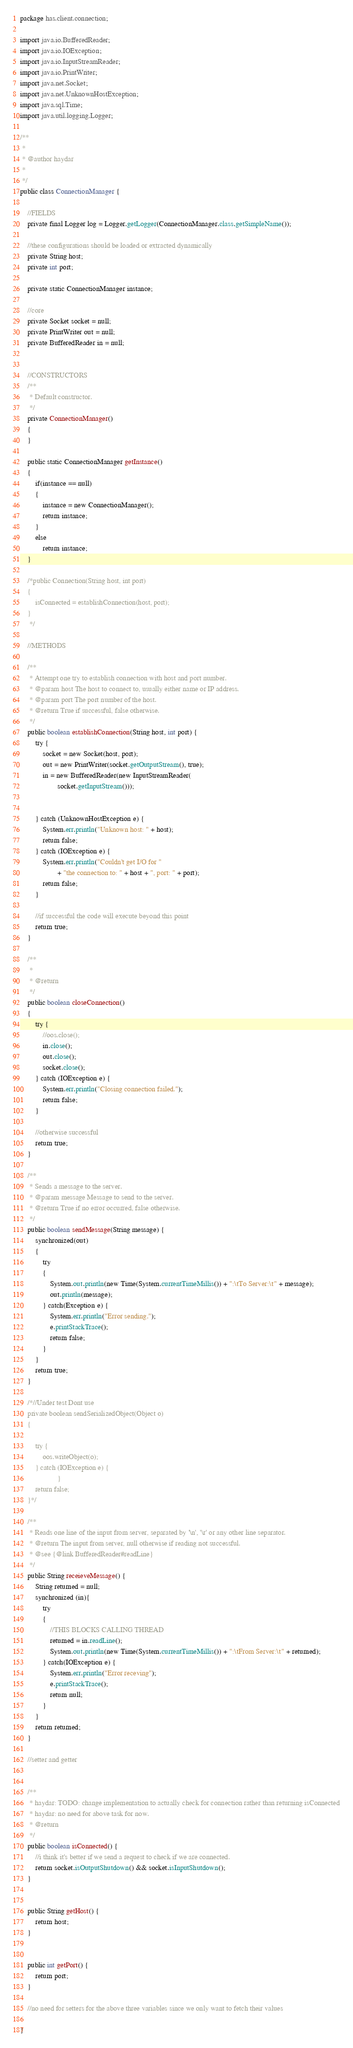Convert code to text. <code><loc_0><loc_0><loc_500><loc_500><_Java_>package has.client.connection;

import java.io.BufferedReader;
import java.io.IOException;
import java.io.InputStreamReader;
import java.io.PrintWriter;
import java.net.Socket;
import java.net.UnknownHostException;
import java.sql.Time;
import java.util.logging.Logger;

/**
 * 
 * @author haydar
 *
 */
public class ConnectionManager {

	//FIELDS
	private final Logger log = Logger.getLogger(ConnectionManager.class.getSimpleName());

	//these configurations should be loaded or extracted dynamically
	private String host;
	private int port;

	private static ConnectionManager instance;

	//core
	private Socket socket = null;
	private PrintWriter out = null;
	private BufferedReader in = null;


	//CONSTRUCTORS
	/**
	 * Default constructor.
	 */
	private ConnectionManager()
	{
	}

	public static ConnectionManager getInstance()
	{
		if(instance == null)
		{
			instance = new ConnectionManager();
			return instance;
		}
		else 
			return instance;
	}

	/*public Connection(String host, int port)
	{
		isConnected = establishConnection(host, port);
	}
	 */

	//METHODS

	/**
	 * Attempt one try to establish connection with host and port number.
	 * @param host The host to connect to, usually either name or IP address.
	 * @param port The port number of the host.
	 * @return True if successful, false otherwise.
	 */
	public boolean establishConnection(String host, int port) {
		try {
			socket = new Socket(host, port);
			out = new PrintWriter(socket.getOutputStream(), true);
			in = new BufferedReader(new InputStreamReader(
					socket.getInputStream()));


		} catch (UnknownHostException e) {
			System.err.println("Unknown host: " + host);
			return false;
		} catch (IOException e) {
			System.err.println("Couldn't get I/O for "
					+ "the connection to: " + host + ", port: " + port);
			return false;
		}

		//if successful the code will execute beyond this point
		return true;
	}

	/**
	 * 
	 * @return
	 */
	public boolean closeConnection()
	{
		try {
			//oos.close();
			in.close();
			out.close();
			socket.close();
		} catch (IOException e) {
			System.err.println("Closing connection failed.");
			return false;		
		}

		//otherwise successful
		return true;
	}

	/**
	 * Sends a message to the server.
	 * @param message Message to send to the server.
	 * @return True if no error occurred, false otherwise.
	 */
	public boolean sendMessage(String message) {
		synchronized(out)
		{
			try 
			{ 
				System.out.println(new Time(System.currentTimeMillis()) + ":\tTo Server:\t" + message);
				out.println(message);
			} catch(Exception e) {
				System.err.println("Error sending.");
				e.printStackTrace();
				return false;
			}
		}
		return true;
	}

	/*//Under test Dont use
	private boolean sendSerializedObject(Object o)
	{

		try {
			oos.writeObject(o);
		} catch (IOException e) {
					}
		return false;
	}*/

	/**
	 * Reads one line of the input from server, separated by '\n', '\r' or any other line separator.
	 * @return The input from server, null otherwise if reading not successful.
	 * @see {@link BufferedReader#readLine}
	 */
	public String receieveMessage() {
		String returned = null;
		synchronized (in){
			try 
			{ 
				//THIS BLOCKS CALLING THREAD
				returned = in.readLine();
				System.out.println(new Time(System.currentTimeMillis()) + ":\tFrom Server:\t" + returned);
			} catch(IOException e) {
				System.err.println("Error receving");
				e.printStackTrace();
				return null;
			}
		}
		return returned;
	}

	//setter and getter


	/**
	 * haydar: TODO: change implementation to actually check for connection rather than returning isConnected
	 * haydar: no need for above task for now.
	 * @return
	 */
	public boolean isConnected() {
		//i think it's better if we send a request to check if we are connected.
		return socket.isOutputShutdown() && socket.isInputShutdown(); 
	}


	public String getHost() {
		return host;
	}


	public int getPort() {
		return port;
	}

	//no need for setters for the above three variables since we only want to fetch their values

}
</code> 